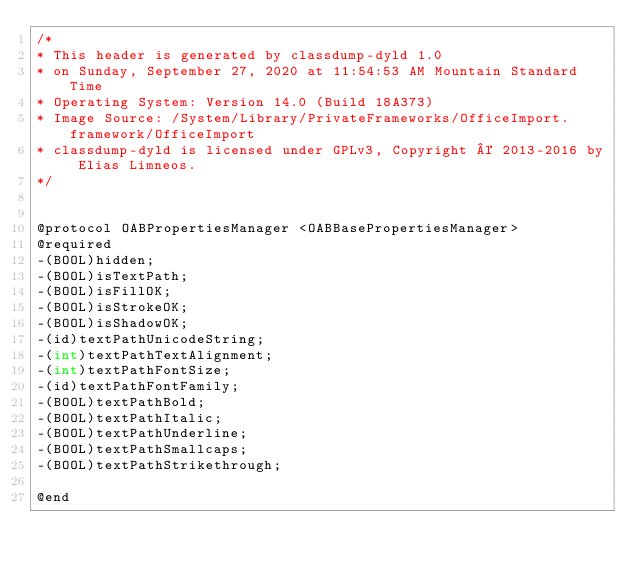<code> <loc_0><loc_0><loc_500><loc_500><_C_>/*
* This header is generated by classdump-dyld 1.0
* on Sunday, September 27, 2020 at 11:54:53 AM Mountain Standard Time
* Operating System: Version 14.0 (Build 18A373)
* Image Source: /System/Library/PrivateFrameworks/OfficeImport.framework/OfficeImport
* classdump-dyld is licensed under GPLv3, Copyright © 2013-2016 by Elias Limneos.
*/


@protocol OABPropertiesManager <OABBasePropertiesManager>
@required
-(BOOL)hidden;
-(BOOL)isTextPath;
-(BOOL)isFillOK;
-(BOOL)isStrokeOK;
-(BOOL)isShadowOK;
-(id)textPathUnicodeString;
-(int)textPathTextAlignment;
-(int)textPathFontSize;
-(id)textPathFontFamily;
-(BOOL)textPathBold;
-(BOOL)textPathItalic;
-(BOOL)textPathUnderline;
-(BOOL)textPathSmallcaps;
-(BOOL)textPathStrikethrough;

@end

</code> 